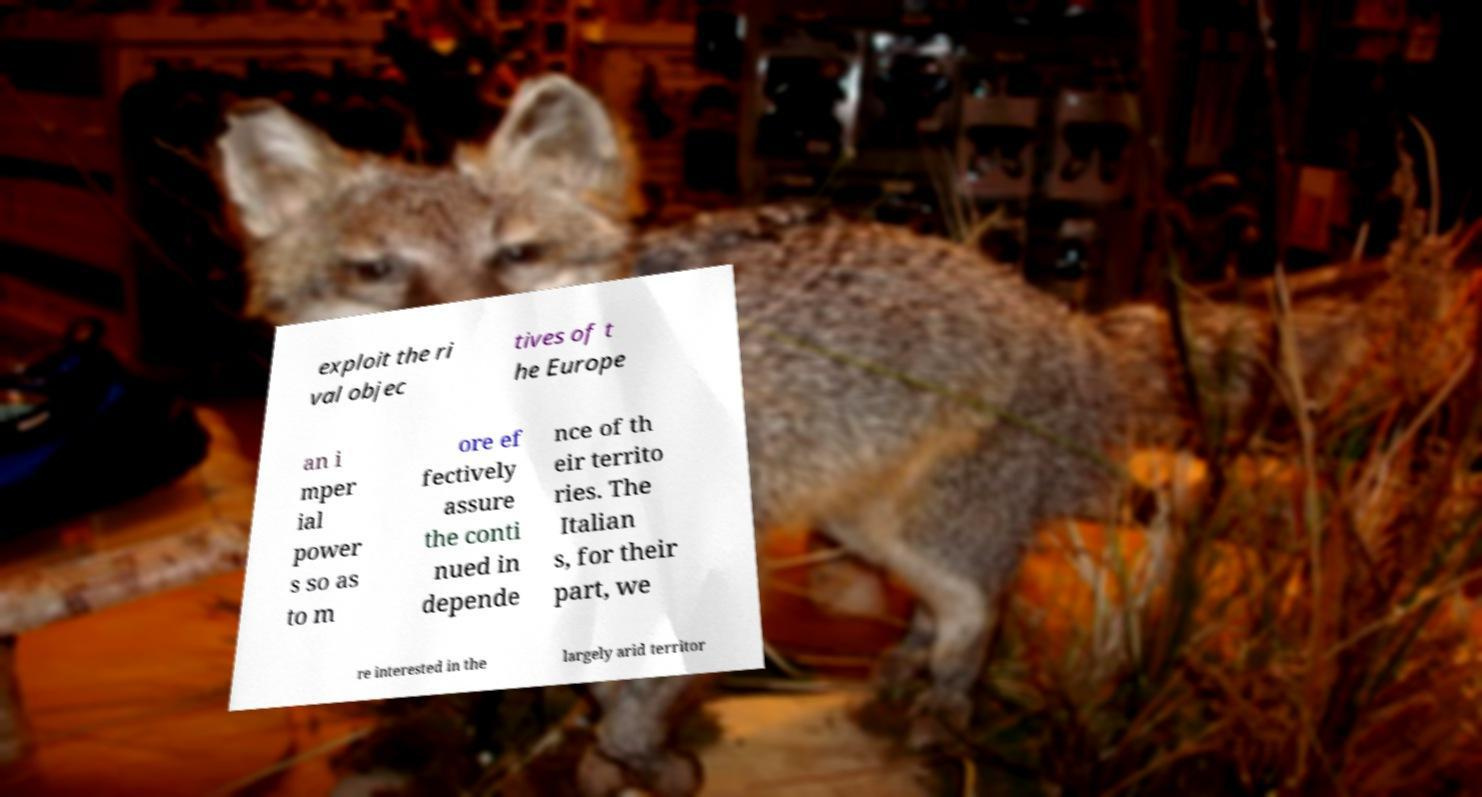There's text embedded in this image that I need extracted. Can you transcribe it verbatim? exploit the ri val objec tives of t he Europe an i mper ial power s so as to m ore ef fectively assure the conti nued in depende nce of th eir territo ries. The Italian s, for their part, we re interested in the largely arid territor 